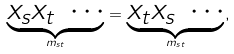Convert formula to latex. <formula><loc_0><loc_0><loc_500><loc_500>\underbrace { x _ { s } x _ { t } \ \cdots } _ { m _ { s t } } = \underbrace { x _ { t } x _ { s } \ \cdots } _ { m _ { s t } } ,</formula> 